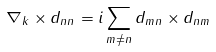<formula> <loc_0><loc_0><loc_500><loc_500>\nabla _ { k } \times { d _ { n n } } = i \sum _ { m \neq n } { d _ { m n } } \times { d _ { n m } }</formula> 